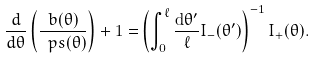Convert formula to latex. <formula><loc_0><loc_0><loc_500><loc_500>\frac { d } { d \theta } \left ( \frac { b ( \theta ) } { \ p s ( \theta ) } \right ) + 1 = & \left ( \int _ { 0 } ^ { \ell } \frac { { \mathrm d } \theta ^ { \prime } } { \ell } I _ { - } ( \theta ^ { \prime } ) \right ) ^ { - 1 } I _ { + } ( \theta ) .</formula> 